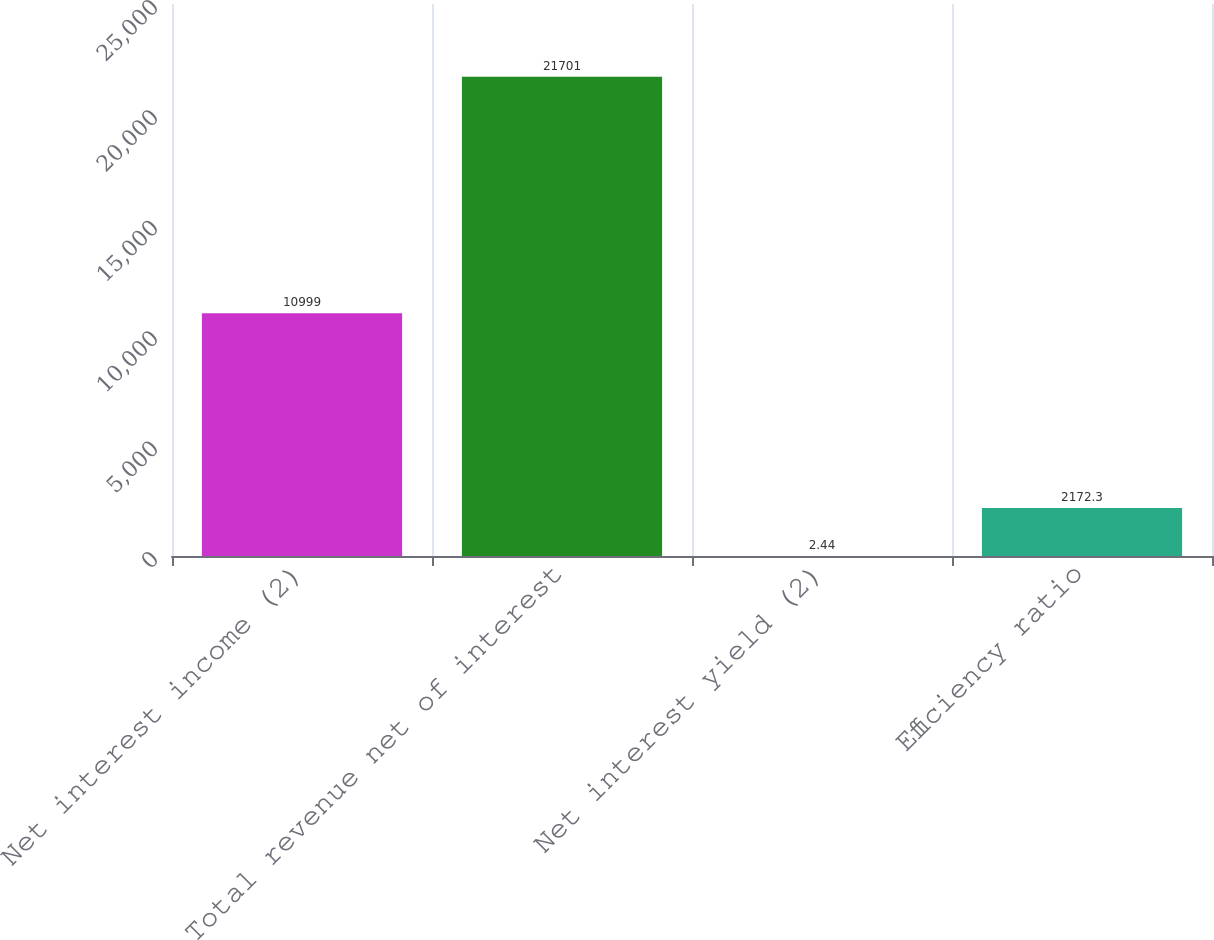Convert chart to OTSL. <chart><loc_0><loc_0><loc_500><loc_500><bar_chart><fcel>Net interest income (2)<fcel>Total revenue net of interest<fcel>Net interest yield (2)<fcel>Efficiency ratio<nl><fcel>10999<fcel>21701<fcel>2.44<fcel>2172.3<nl></chart> 